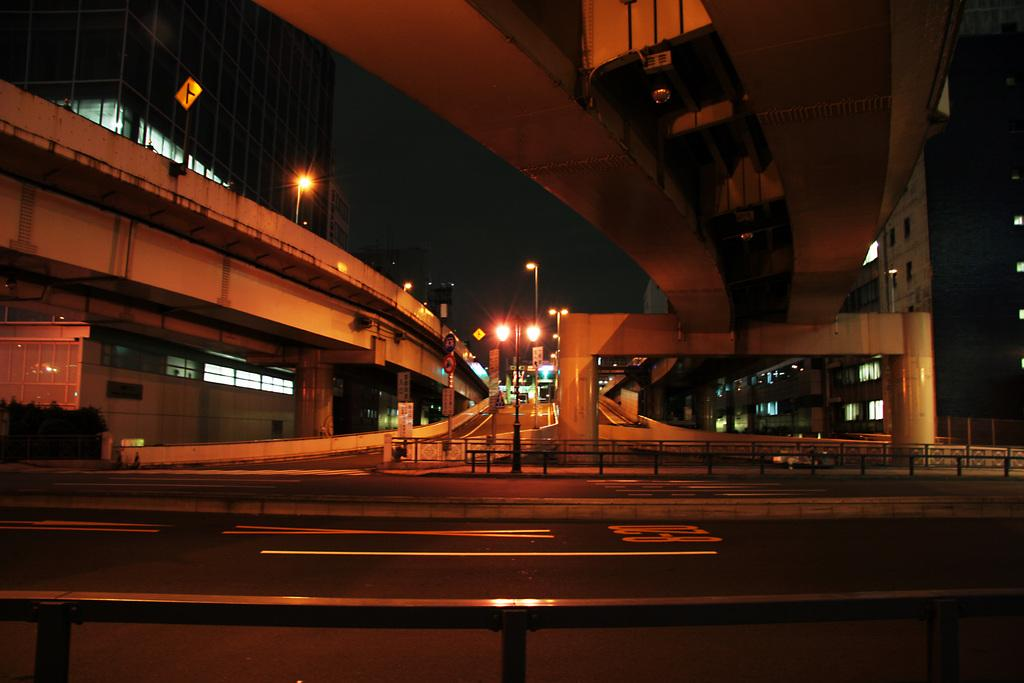What type of infrastructure is present in the image? There is a road and a flyover in the image. What else can be seen in the image besides the road and flyover? There are buildings, street lights, pillars, and plants visible in the image. Can you see any fish swimming in the image? There are no fish present in the image. What type of snail is crawling on the pillar in the image? There is no snail present in the image. 